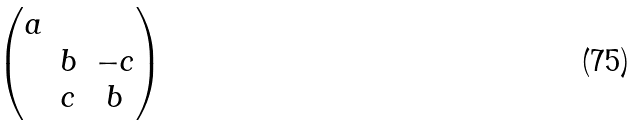Convert formula to latex. <formula><loc_0><loc_0><loc_500><loc_500>\begin{pmatrix} a & & \\ & b & - c \\ & c & b \end{pmatrix}</formula> 